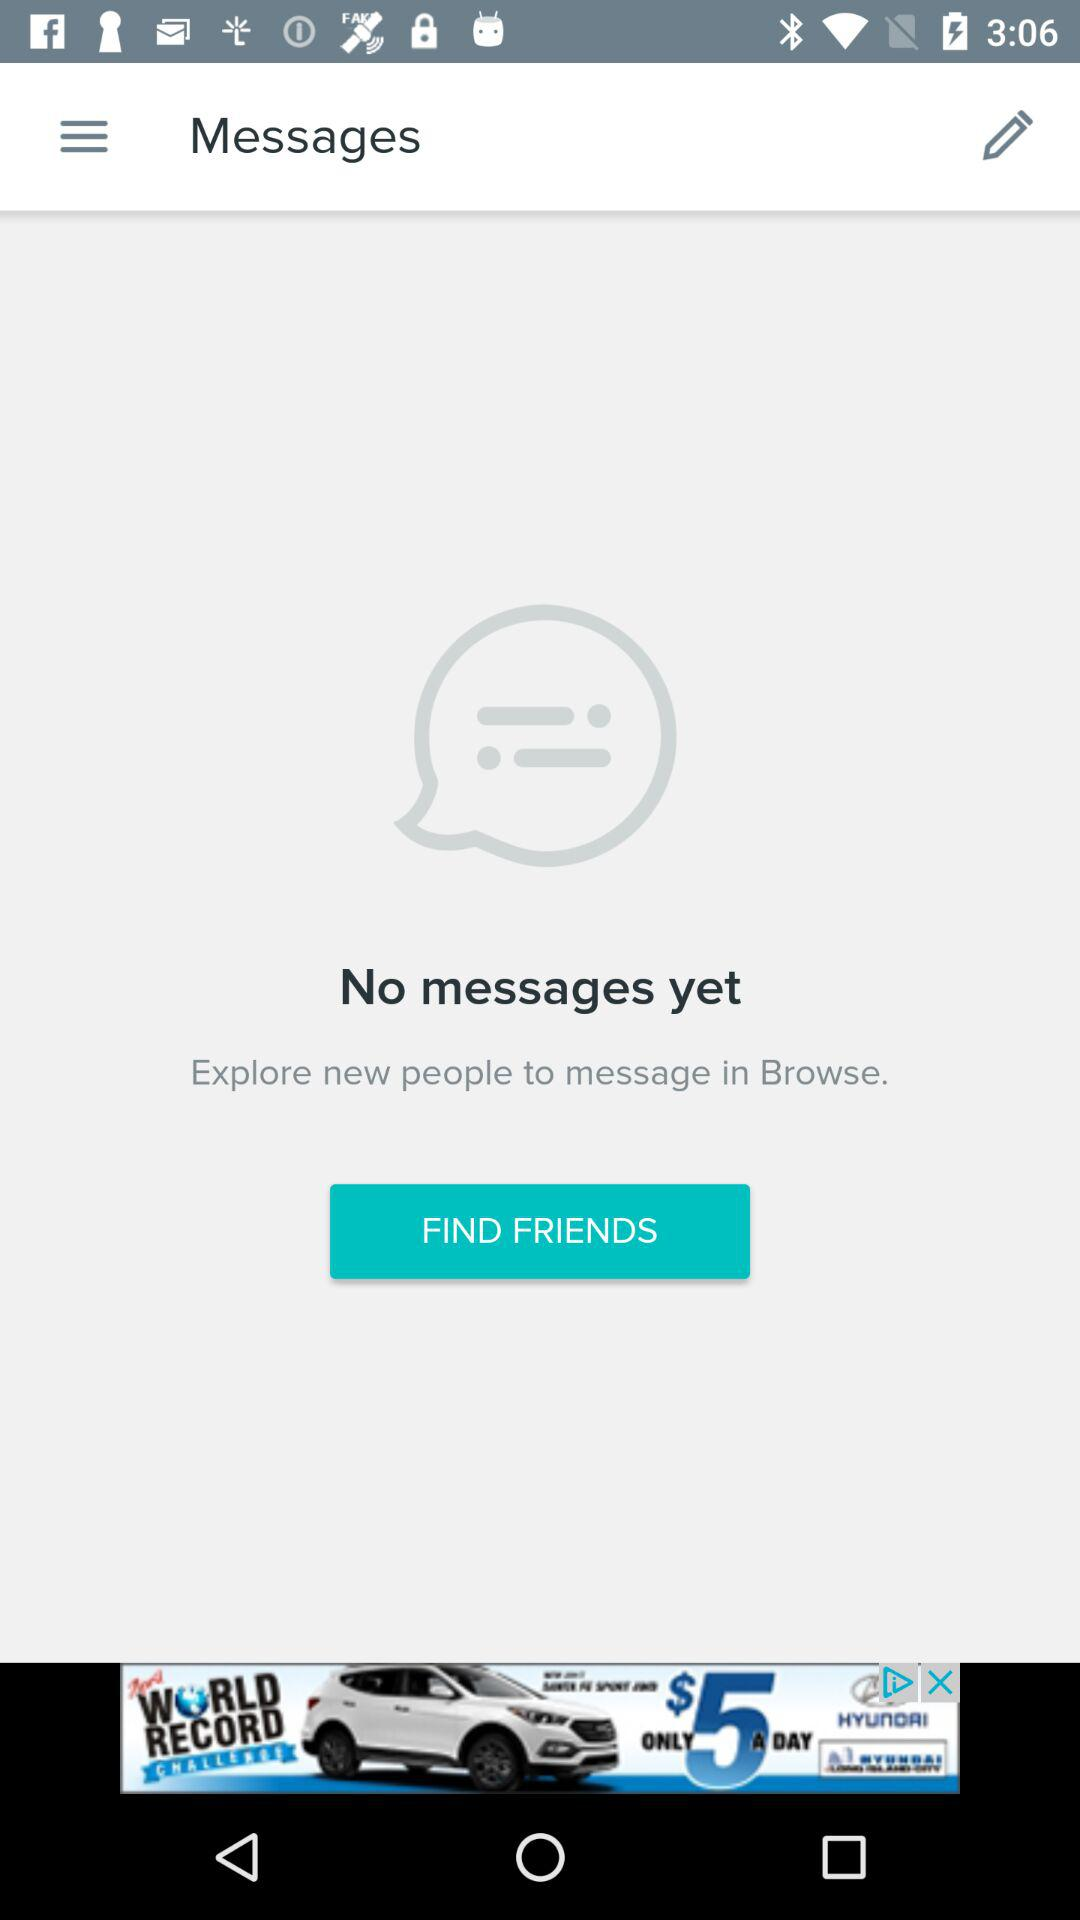Is there any message found? There is no message found. 